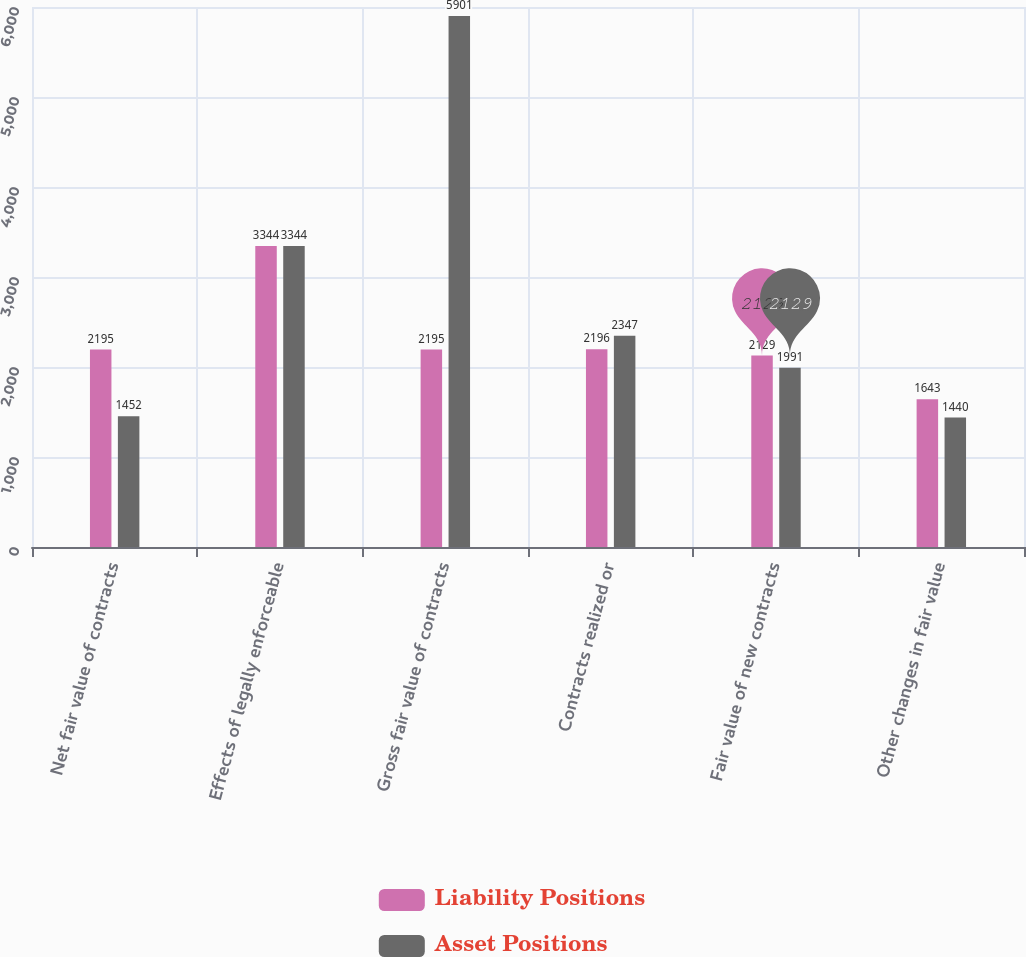Convert chart to OTSL. <chart><loc_0><loc_0><loc_500><loc_500><stacked_bar_chart><ecel><fcel>Net fair value of contracts<fcel>Effects of legally enforceable<fcel>Gross fair value of contracts<fcel>Contracts realized or<fcel>Fair value of new contracts<fcel>Other changes in fair value<nl><fcel>Liability Positions<fcel>2195<fcel>3344<fcel>2195<fcel>2196<fcel>2129<fcel>1643<nl><fcel>Asset Positions<fcel>1452<fcel>3344<fcel>5901<fcel>2347<fcel>1991<fcel>1440<nl></chart> 